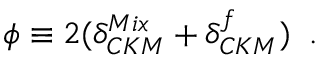Convert formula to latex. <formula><loc_0><loc_0><loc_500><loc_500>\phi \equiv 2 ( \delta _ { C K M } ^ { M i x } + \delta _ { C K M } ^ { f } ) \, .</formula> 